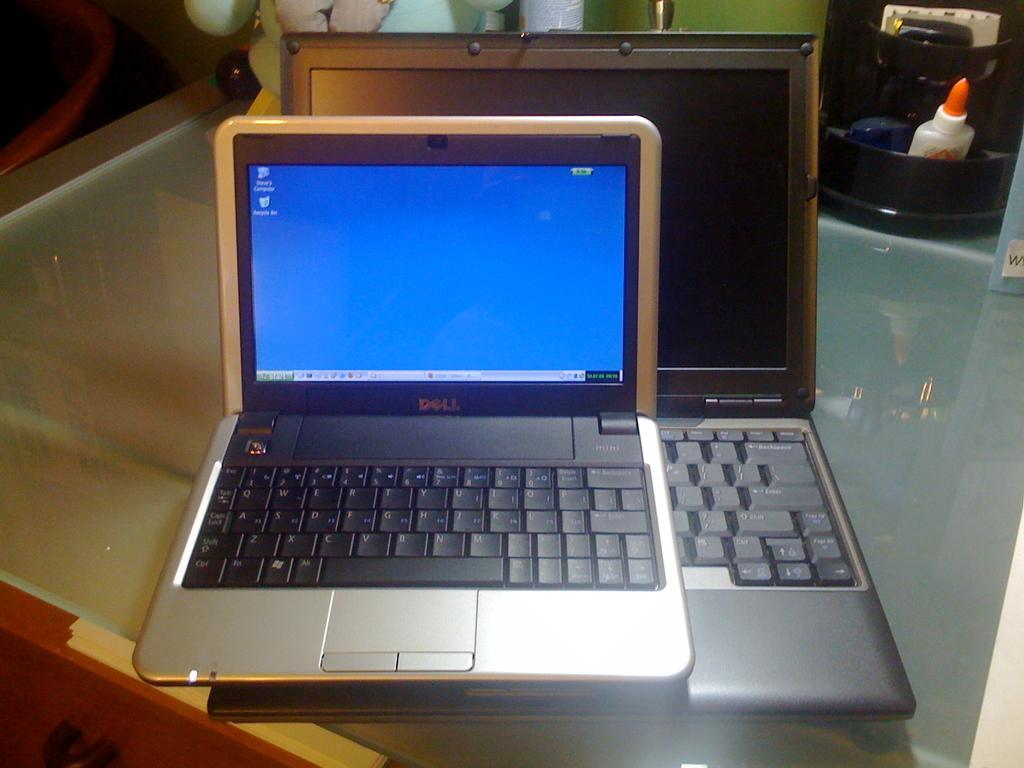Describe this image in one or two sentences. In the middle of the image we can see few laptops on the table, and we can find few things in the background. 